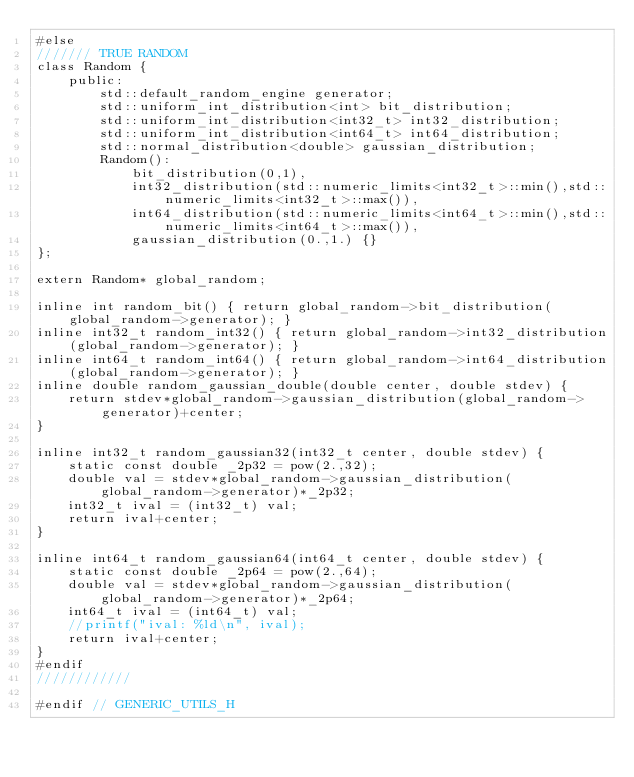Convert code to text. <code><loc_0><loc_0><loc_500><loc_500><_C_>#else
/////// TRUE RANDOM
class Random {
    public:
        std::default_random_engine generator;
        std::uniform_int_distribution<int> bit_distribution;
        std::uniform_int_distribution<int32_t> int32_distribution;
        std::uniform_int_distribution<int64_t> int64_distribution;
        std::normal_distribution<double> gaussian_distribution;
        Random():
            bit_distribution(0,1),
            int32_distribution(std::numeric_limits<int32_t>::min(),std::numeric_limits<int32_t>::max()),
            int64_distribution(std::numeric_limits<int64_t>::min(),std::numeric_limits<int64_t>::max()),
            gaussian_distribution(0.,1.) {}
};

extern Random* global_random; 

inline int random_bit() { return global_random->bit_distribution(global_random->generator); }
inline int32_t random_int32() { return global_random->int32_distribution(global_random->generator); }
inline int64_t random_int64() { return global_random->int64_distribution(global_random->generator); }
inline double random_gaussian_double(double center, double stdev) { 
    return stdev*global_random->gaussian_distribution(global_random->generator)+center; 
}

inline int32_t random_gaussian32(int32_t center, double stdev) {
    static const double _2p32 = pow(2.,32);
    double val = stdev*global_random->gaussian_distribution(global_random->generator)*_2p32;
    int32_t ival = (int32_t) val;
    return ival+center;    
}

inline int64_t random_gaussian64(int64_t center, double stdev) {
    static const double _2p64 = pow(2.,64);
    double val = stdev*global_random->gaussian_distribution(global_random->generator)*_2p64;
    int64_t ival = (int64_t) val;
    //printf("ival: %ld\n", ival);
    return ival+center;    
}
#endif
////////////

#endif // GENERIC_UTILS_H
</code> 